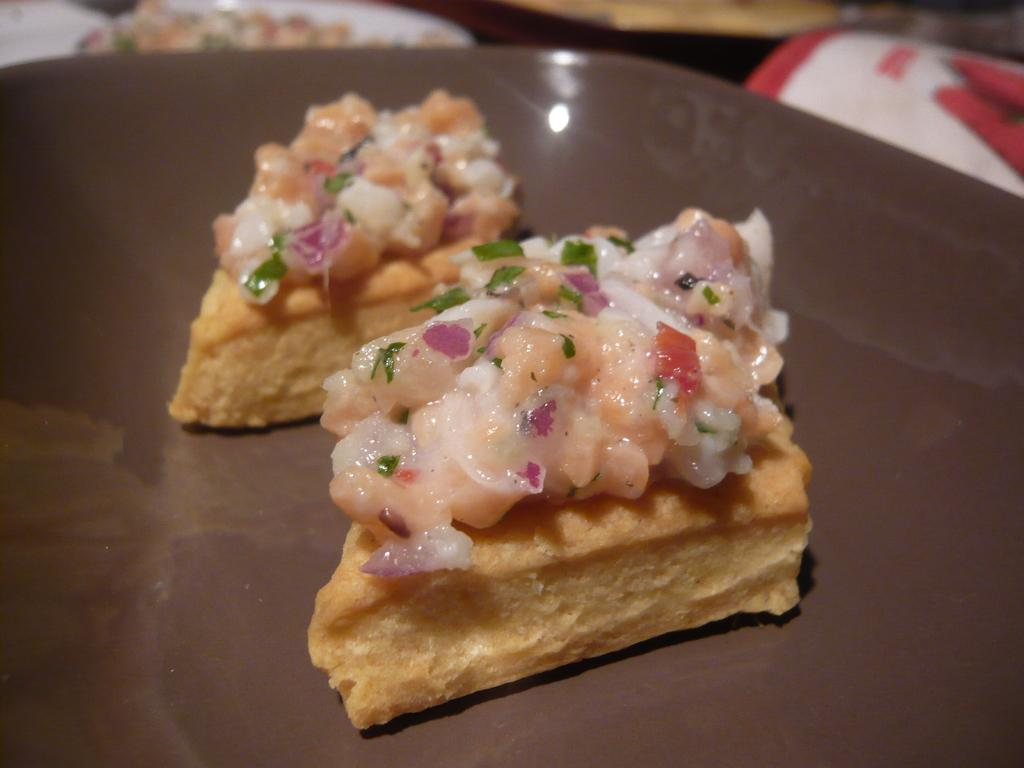What is on the plate that is visible in the image? There is food on a plate in the image. What is the color of the plate? The plate is brown in color. How many girls are present in the image? There is no mention of girls in the provided facts, so we cannot determine their presence in the image. 